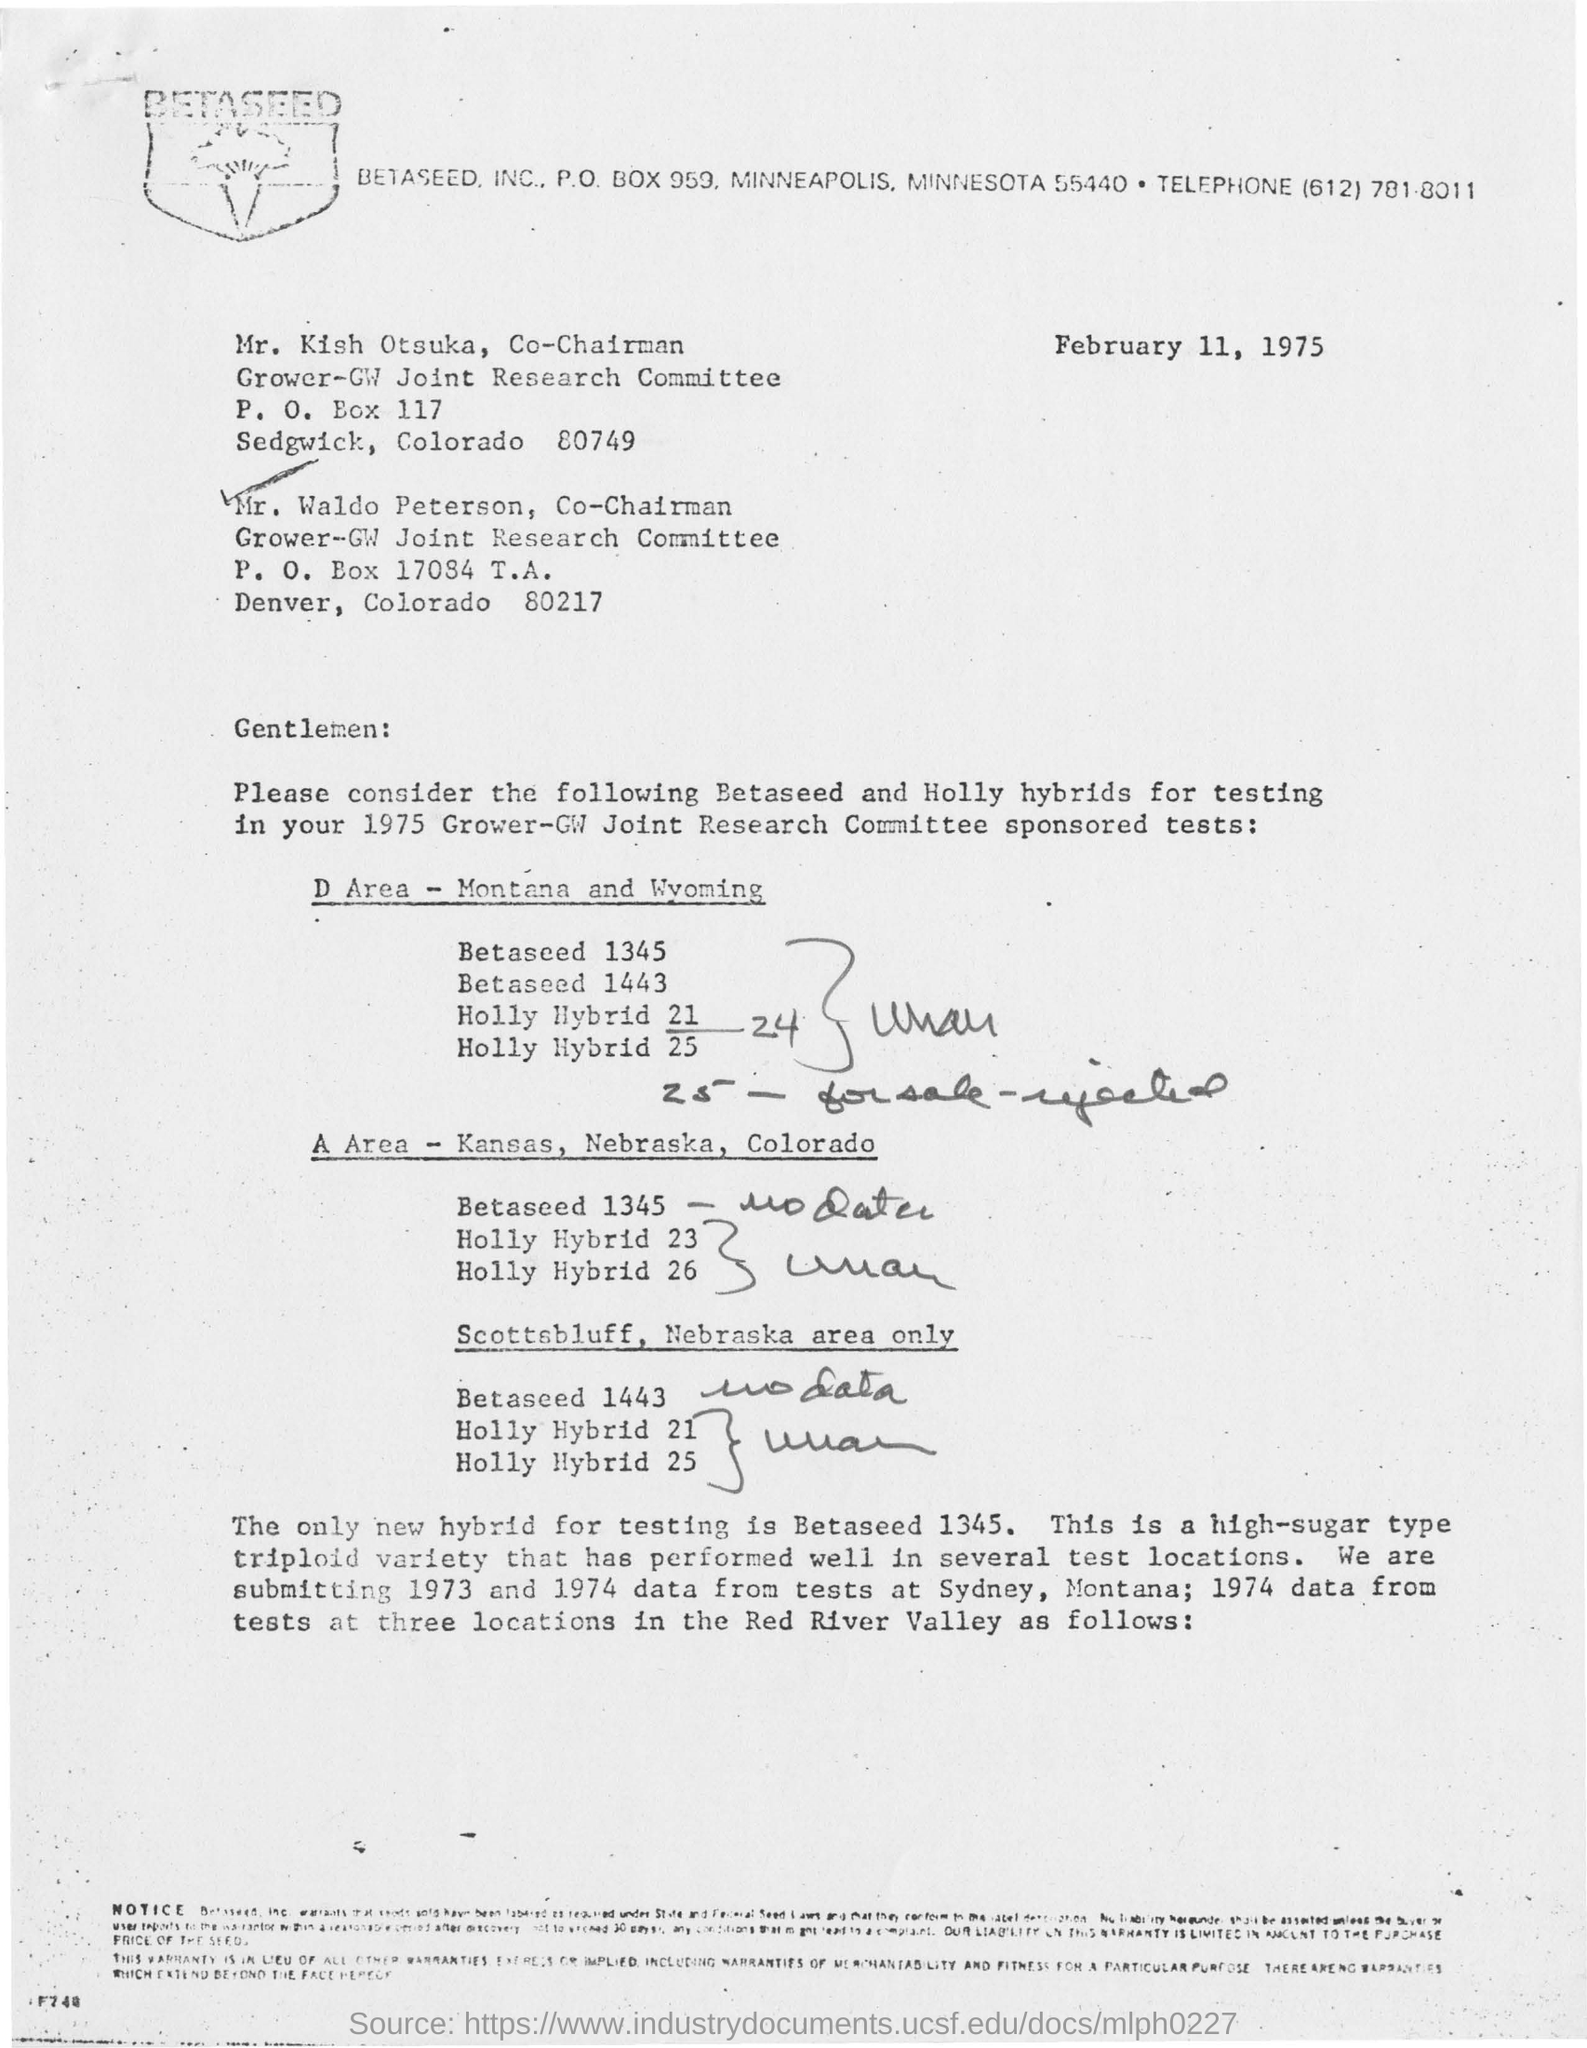Which company is mentioned in the letterhead?
Your response must be concise. BETASEED, INC. What is company's Post Box number?
Provide a succinct answer. 959. What is the date mentioned in the document?
Your response must be concise. February 11, 1975. What is the Designation of KIsh Otsuka?
Keep it short and to the point. Co-Chairman. What is the designation of  mr. waldo peterson
Ensure brevity in your answer.  Co-Chairman. 